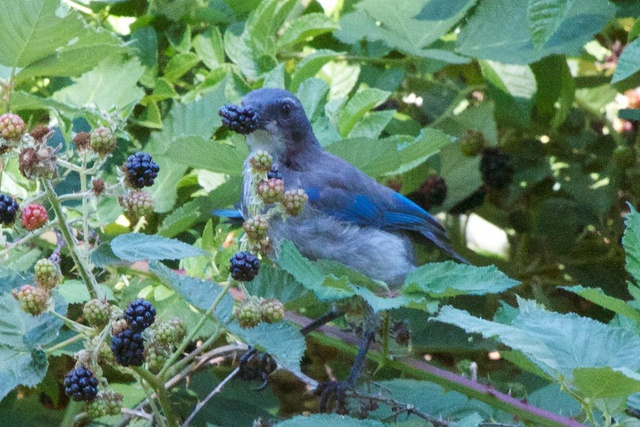Describe the objects in this image and their specific colors. I can see a bird in lightgreen, gray, and blue tones in this image. 